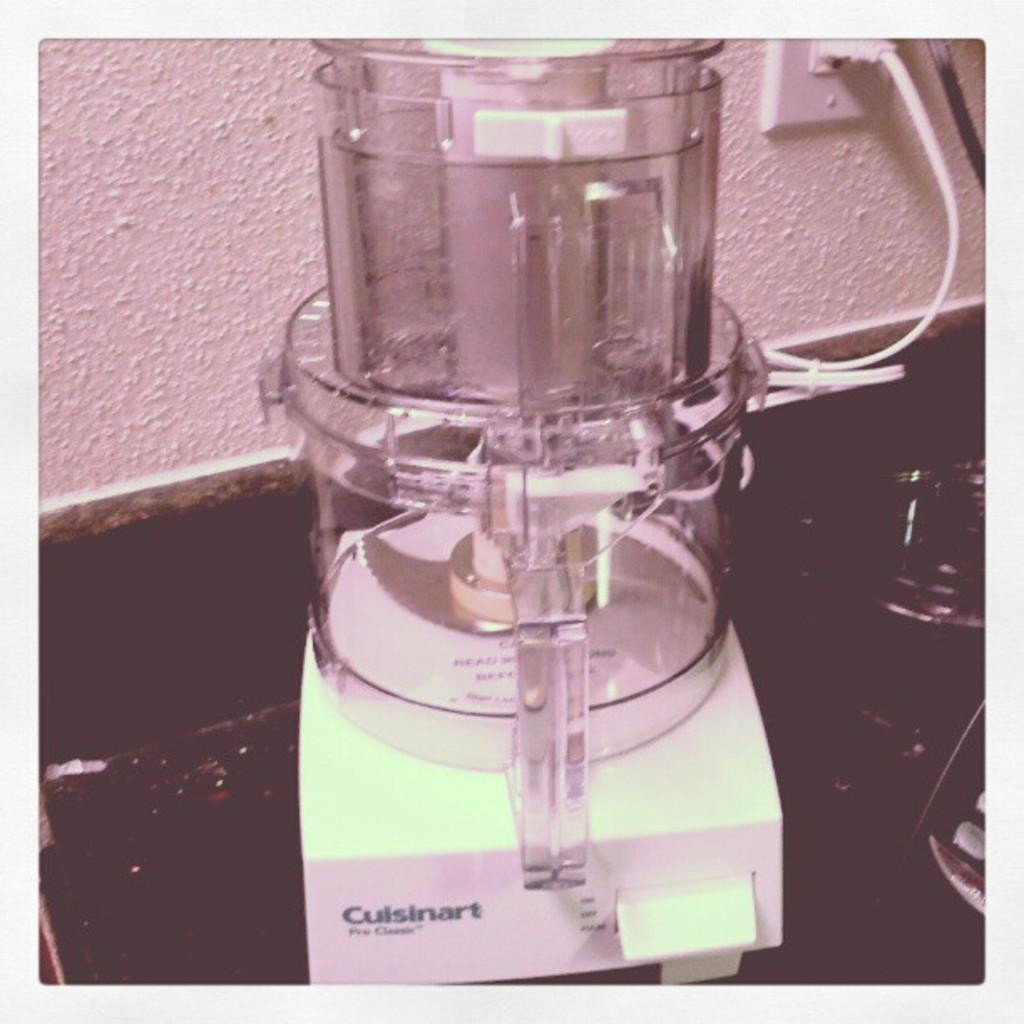<image>
Relay a brief, clear account of the picture shown. A white based Cuisinart is plugged in and sitting on a counter. 